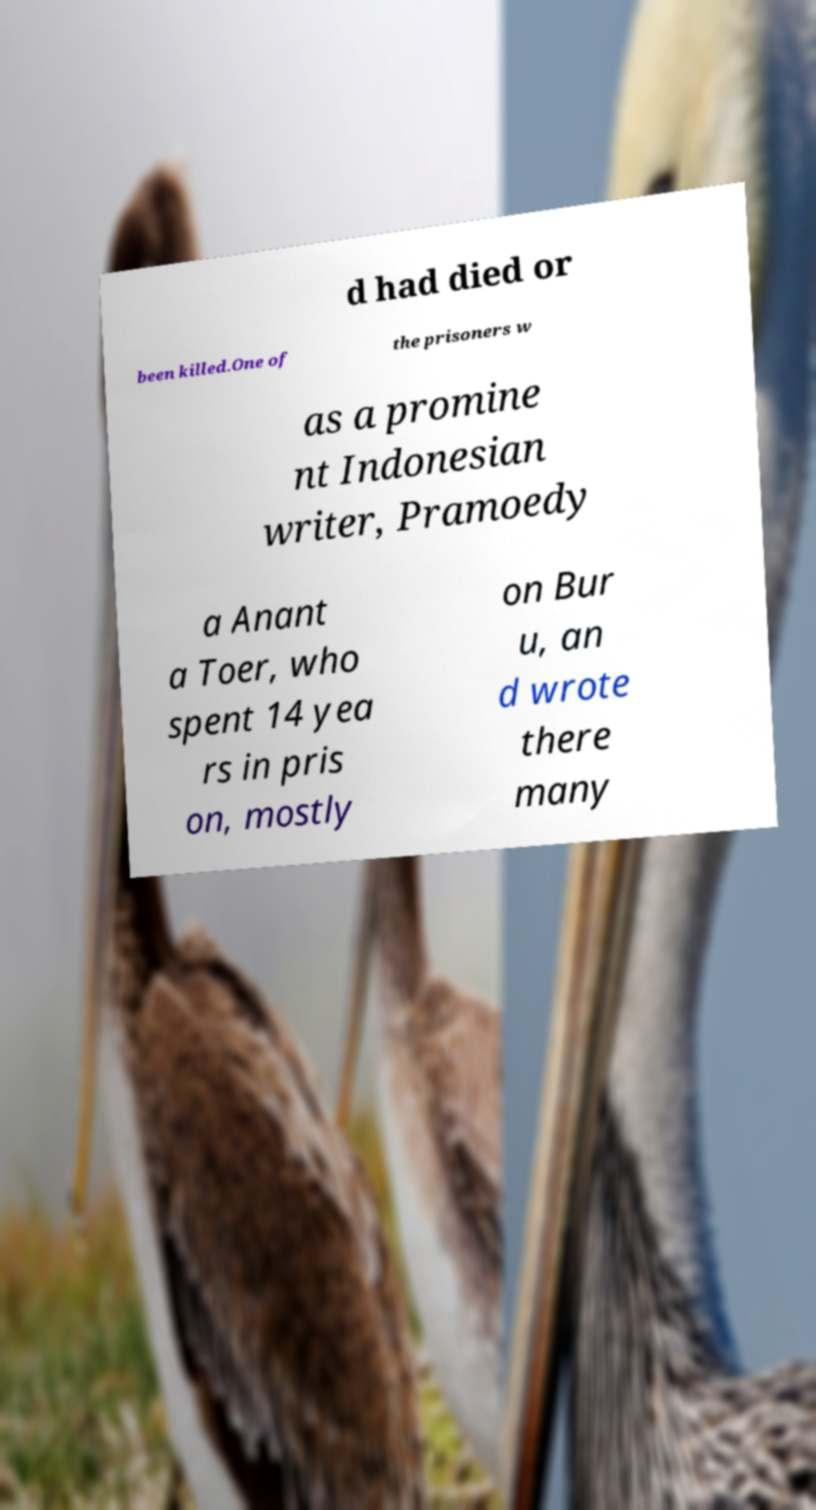Could you assist in decoding the text presented in this image and type it out clearly? d had died or been killed.One of the prisoners w as a promine nt Indonesian writer, Pramoedy a Anant a Toer, who spent 14 yea rs in pris on, mostly on Bur u, an d wrote there many 